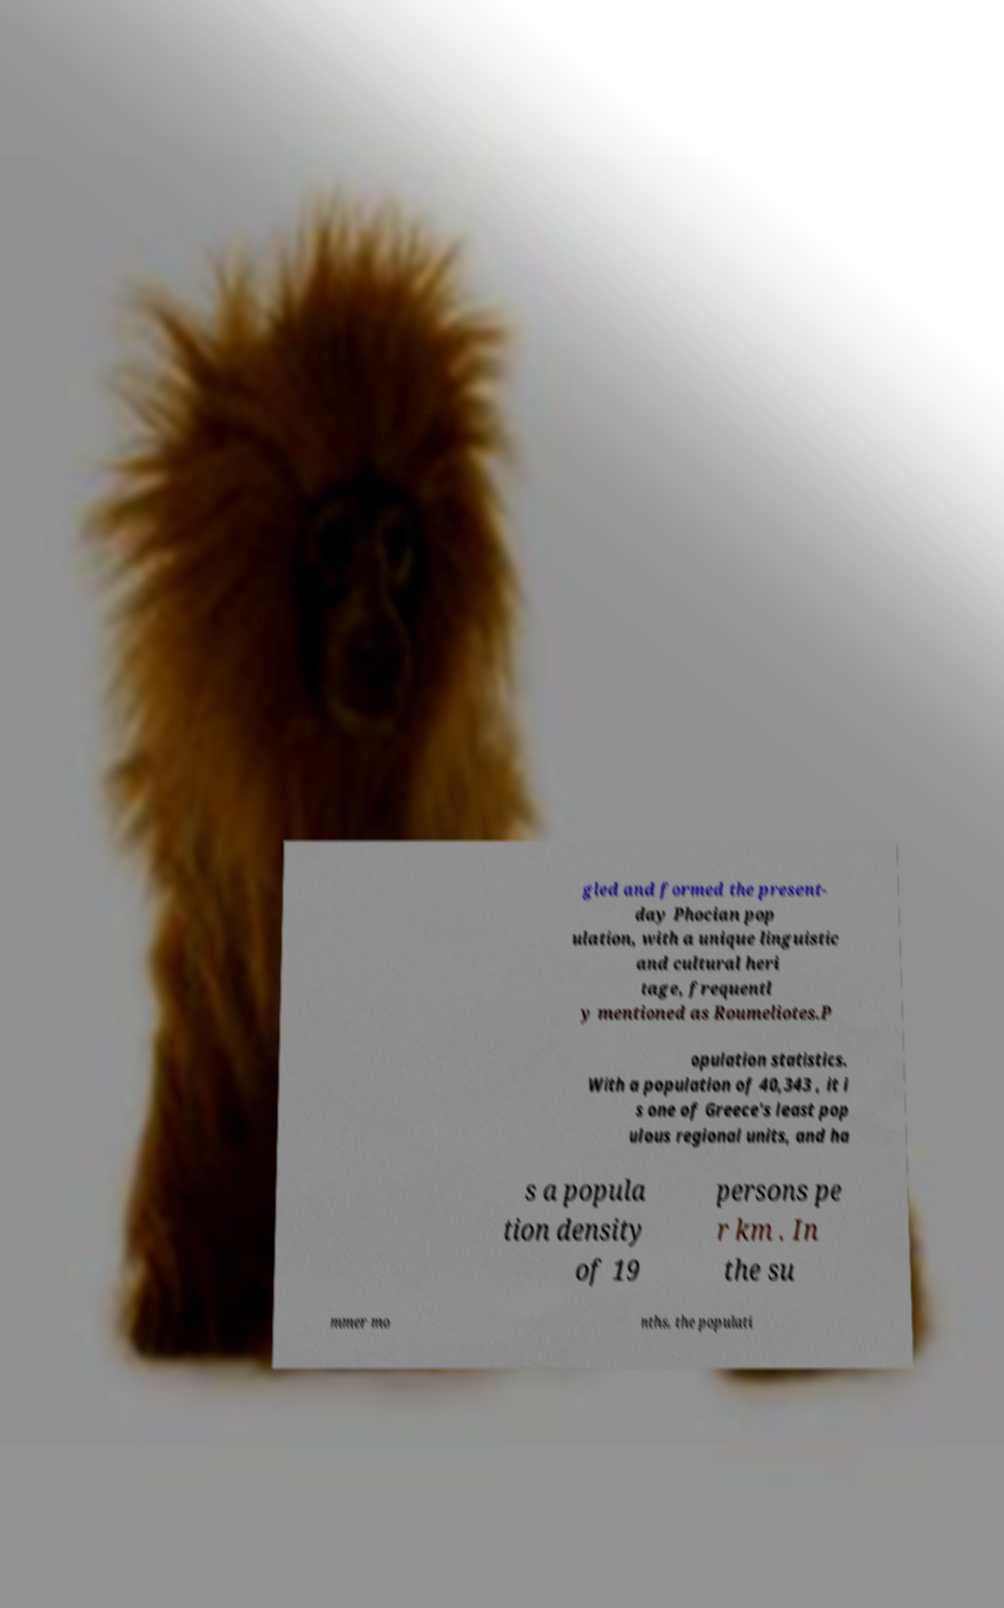Could you extract and type out the text from this image? gled and formed the present- day Phocian pop ulation, with a unique linguistic and cultural heri tage, frequentl y mentioned as Roumeliotes.P opulation statistics. With a population of 40,343 , it i s one of Greece's least pop ulous regional units, and ha s a popula tion density of 19 persons pe r km . In the su mmer mo nths, the populati 